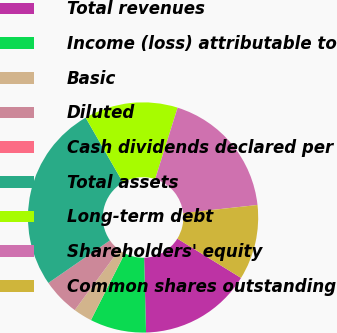Convert chart. <chart><loc_0><loc_0><loc_500><loc_500><pie_chart><fcel>Total revenues<fcel>Income (loss) attributable to<fcel>Basic<fcel>Diluted<fcel>Cash dividends declared per<fcel>Total assets<fcel>Long-term debt<fcel>Shareholders' equity<fcel>Common shares outstanding<nl><fcel>15.79%<fcel>7.89%<fcel>2.63%<fcel>5.26%<fcel>0.0%<fcel>26.32%<fcel>13.16%<fcel>18.42%<fcel>10.53%<nl></chart> 